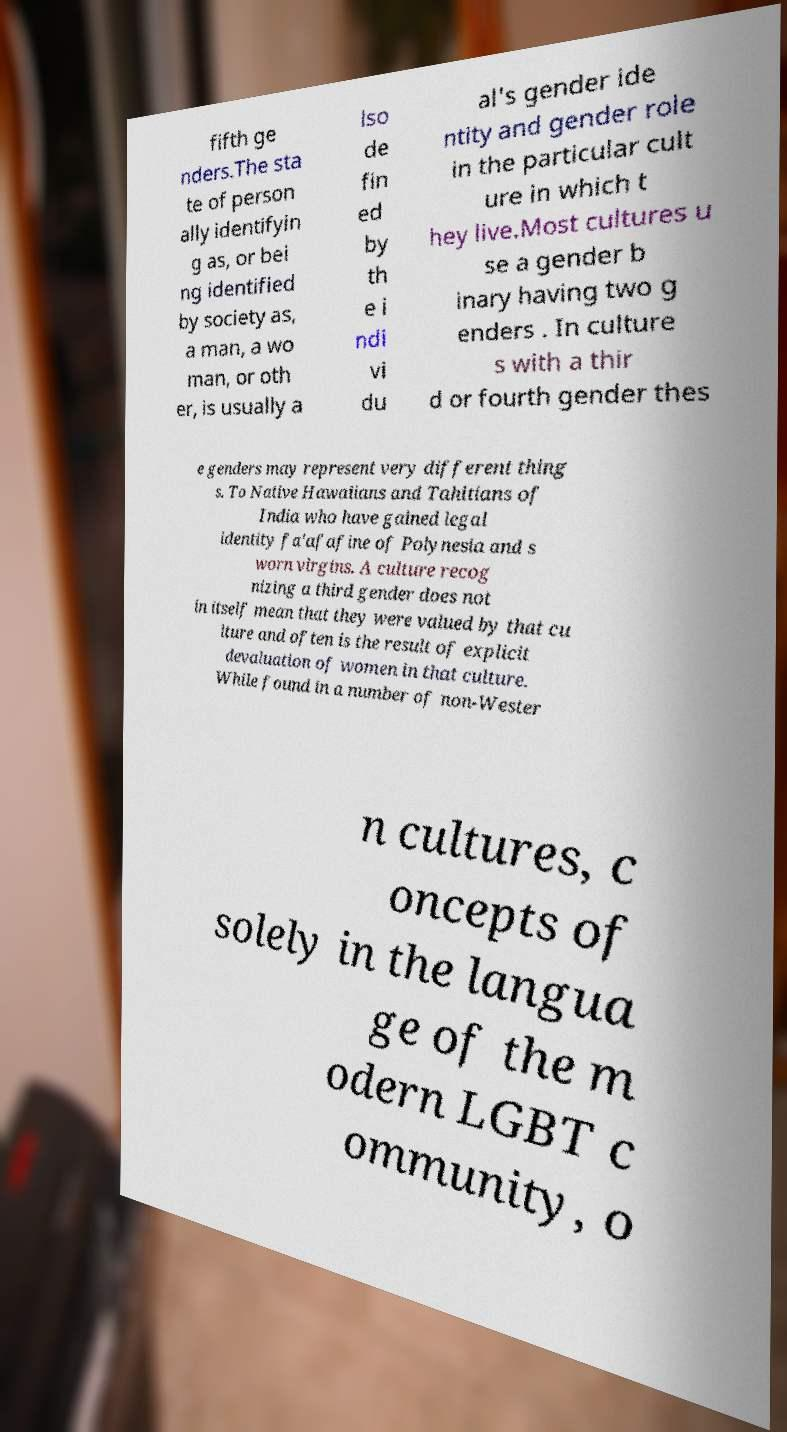What messages or text are displayed in this image? I need them in a readable, typed format. fifth ge nders.The sta te of person ally identifyin g as, or bei ng identified by society as, a man, a wo man, or oth er, is usually a lso de fin ed by th e i ndi vi du al's gender ide ntity and gender role in the particular cult ure in which t hey live.Most cultures u se a gender b inary having two g enders . In culture s with a thir d or fourth gender thes e genders may represent very different thing s. To Native Hawaiians and Tahitians of India who have gained legal identity fa'afafine of Polynesia and s worn virgins. A culture recog nizing a third gender does not in itself mean that they were valued by that cu lture and often is the result of explicit devaluation of women in that culture. While found in a number of non-Wester n cultures, c oncepts of solely in the langua ge of the m odern LGBT c ommunity, o 